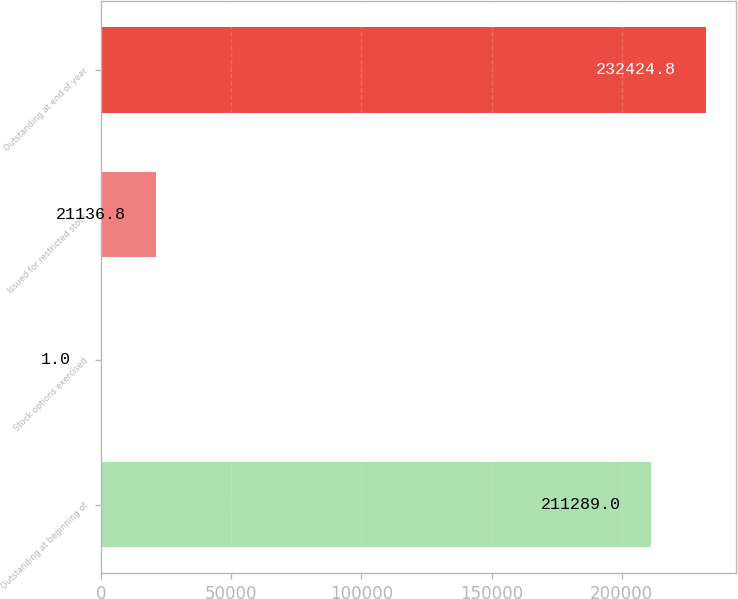<chart> <loc_0><loc_0><loc_500><loc_500><bar_chart><fcel>Outstanding at beginning of<fcel>Stock options exercised<fcel>Issued for restricted stock<fcel>Outstanding at end of year<nl><fcel>211289<fcel>1<fcel>21136.8<fcel>232425<nl></chart> 